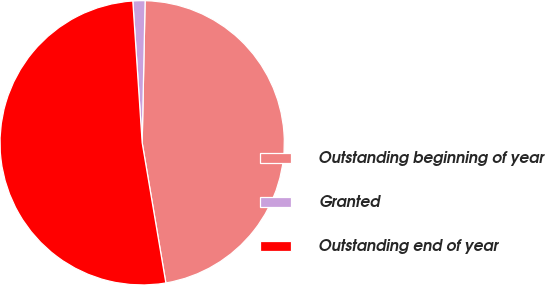Convert chart to OTSL. <chart><loc_0><loc_0><loc_500><loc_500><pie_chart><fcel>Outstanding beginning of year<fcel>Granted<fcel>Outstanding end of year<nl><fcel>47.01%<fcel>1.38%<fcel>51.62%<nl></chart> 